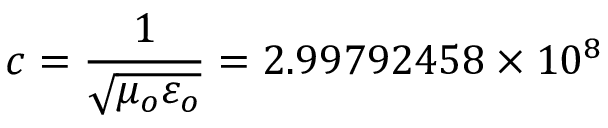<formula> <loc_0><loc_0><loc_500><loc_500>c = { \frac { 1 } { \sqrt { \mu _ { o } \varepsilon _ { o } } } } = 2 . 9 9 7 9 2 4 5 8 \times 1 0 ^ { 8 }</formula> 